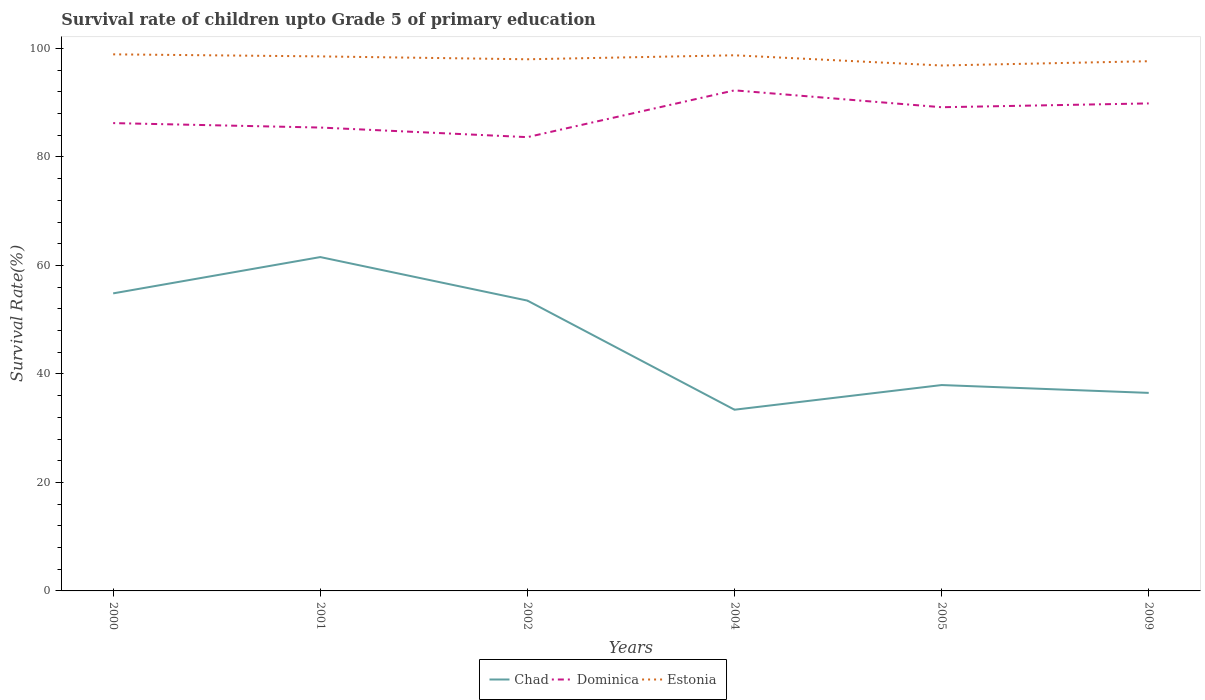Does the line corresponding to Dominica intersect with the line corresponding to Estonia?
Give a very brief answer. No. Across all years, what is the maximum survival rate of children in Estonia?
Provide a succinct answer. 96.86. In which year was the survival rate of children in Chad maximum?
Keep it short and to the point. 2004. What is the total survival rate of children in Chad in the graph?
Provide a succinct answer. -6.69. What is the difference between the highest and the second highest survival rate of children in Dominica?
Your answer should be compact. 8.63. Is the survival rate of children in Estonia strictly greater than the survival rate of children in Dominica over the years?
Provide a succinct answer. No. Are the values on the major ticks of Y-axis written in scientific E-notation?
Ensure brevity in your answer.  No. How many legend labels are there?
Give a very brief answer. 3. What is the title of the graph?
Ensure brevity in your answer.  Survival rate of children upto Grade 5 of primary education. What is the label or title of the X-axis?
Your answer should be compact. Years. What is the label or title of the Y-axis?
Ensure brevity in your answer.  Survival Rate(%). What is the Survival Rate(%) in Chad in 2000?
Your response must be concise. 54.85. What is the Survival Rate(%) of Dominica in 2000?
Provide a short and direct response. 86.24. What is the Survival Rate(%) of Estonia in 2000?
Offer a very short reply. 98.91. What is the Survival Rate(%) in Chad in 2001?
Your answer should be very brief. 61.54. What is the Survival Rate(%) of Dominica in 2001?
Your answer should be very brief. 85.42. What is the Survival Rate(%) in Estonia in 2001?
Your answer should be compact. 98.54. What is the Survival Rate(%) in Chad in 2002?
Your answer should be compact. 53.52. What is the Survival Rate(%) in Dominica in 2002?
Give a very brief answer. 83.65. What is the Survival Rate(%) of Estonia in 2002?
Your answer should be compact. 98.01. What is the Survival Rate(%) in Chad in 2004?
Provide a short and direct response. 33.41. What is the Survival Rate(%) of Dominica in 2004?
Ensure brevity in your answer.  92.28. What is the Survival Rate(%) of Estonia in 2004?
Offer a very short reply. 98.74. What is the Survival Rate(%) of Chad in 2005?
Your response must be concise. 37.95. What is the Survival Rate(%) of Dominica in 2005?
Your response must be concise. 89.17. What is the Survival Rate(%) of Estonia in 2005?
Your response must be concise. 96.86. What is the Survival Rate(%) of Chad in 2009?
Your response must be concise. 36.51. What is the Survival Rate(%) in Dominica in 2009?
Provide a succinct answer. 89.87. What is the Survival Rate(%) in Estonia in 2009?
Provide a succinct answer. 97.65. Across all years, what is the maximum Survival Rate(%) of Chad?
Ensure brevity in your answer.  61.54. Across all years, what is the maximum Survival Rate(%) in Dominica?
Keep it short and to the point. 92.28. Across all years, what is the maximum Survival Rate(%) in Estonia?
Make the answer very short. 98.91. Across all years, what is the minimum Survival Rate(%) of Chad?
Give a very brief answer. 33.41. Across all years, what is the minimum Survival Rate(%) of Dominica?
Your response must be concise. 83.65. Across all years, what is the minimum Survival Rate(%) of Estonia?
Make the answer very short. 96.86. What is the total Survival Rate(%) in Chad in the graph?
Provide a short and direct response. 277.78. What is the total Survival Rate(%) of Dominica in the graph?
Your response must be concise. 526.62. What is the total Survival Rate(%) of Estonia in the graph?
Provide a succinct answer. 588.7. What is the difference between the Survival Rate(%) in Chad in 2000 and that in 2001?
Make the answer very short. -6.69. What is the difference between the Survival Rate(%) in Dominica in 2000 and that in 2001?
Make the answer very short. 0.82. What is the difference between the Survival Rate(%) of Estonia in 2000 and that in 2001?
Give a very brief answer. 0.38. What is the difference between the Survival Rate(%) in Chad in 2000 and that in 2002?
Offer a terse response. 1.33. What is the difference between the Survival Rate(%) in Dominica in 2000 and that in 2002?
Make the answer very short. 2.59. What is the difference between the Survival Rate(%) of Estonia in 2000 and that in 2002?
Keep it short and to the point. 0.91. What is the difference between the Survival Rate(%) of Chad in 2000 and that in 2004?
Keep it short and to the point. 21.44. What is the difference between the Survival Rate(%) in Dominica in 2000 and that in 2004?
Provide a short and direct response. -6.04. What is the difference between the Survival Rate(%) in Estonia in 2000 and that in 2004?
Offer a very short reply. 0.17. What is the difference between the Survival Rate(%) in Chad in 2000 and that in 2005?
Ensure brevity in your answer.  16.9. What is the difference between the Survival Rate(%) in Dominica in 2000 and that in 2005?
Keep it short and to the point. -2.93. What is the difference between the Survival Rate(%) of Estonia in 2000 and that in 2005?
Provide a short and direct response. 2.06. What is the difference between the Survival Rate(%) of Chad in 2000 and that in 2009?
Your response must be concise. 18.34. What is the difference between the Survival Rate(%) of Dominica in 2000 and that in 2009?
Ensure brevity in your answer.  -3.63. What is the difference between the Survival Rate(%) in Estonia in 2000 and that in 2009?
Offer a terse response. 1.27. What is the difference between the Survival Rate(%) in Chad in 2001 and that in 2002?
Your answer should be compact. 8.02. What is the difference between the Survival Rate(%) of Dominica in 2001 and that in 2002?
Your answer should be compact. 1.77. What is the difference between the Survival Rate(%) in Estonia in 2001 and that in 2002?
Your answer should be very brief. 0.53. What is the difference between the Survival Rate(%) in Chad in 2001 and that in 2004?
Provide a short and direct response. 28.14. What is the difference between the Survival Rate(%) in Dominica in 2001 and that in 2004?
Provide a succinct answer. -6.86. What is the difference between the Survival Rate(%) in Estonia in 2001 and that in 2004?
Provide a short and direct response. -0.2. What is the difference between the Survival Rate(%) of Chad in 2001 and that in 2005?
Ensure brevity in your answer.  23.59. What is the difference between the Survival Rate(%) of Dominica in 2001 and that in 2005?
Offer a terse response. -3.75. What is the difference between the Survival Rate(%) of Estonia in 2001 and that in 2005?
Offer a very short reply. 1.68. What is the difference between the Survival Rate(%) in Chad in 2001 and that in 2009?
Your response must be concise. 25.04. What is the difference between the Survival Rate(%) of Dominica in 2001 and that in 2009?
Keep it short and to the point. -4.45. What is the difference between the Survival Rate(%) in Estonia in 2001 and that in 2009?
Your answer should be very brief. 0.89. What is the difference between the Survival Rate(%) in Chad in 2002 and that in 2004?
Make the answer very short. 20.12. What is the difference between the Survival Rate(%) of Dominica in 2002 and that in 2004?
Your answer should be compact. -8.63. What is the difference between the Survival Rate(%) of Estonia in 2002 and that in 2004?
Give a very brief answer. -0.73. What is the difference between the Survival Rate(%) of Chad in 2002 and that in 2005?
Provide a succinct answer. 15.57. What is the difference between the Survival Rate(%) in Dominica in 2002 and that in 2005?
Your response must be concise. -5.51. What is the difference between the Survival Rate(%) in Estonia in 2002 and that in 2005?
Provide a short and direct response. 1.15. What is the difference between the Survival Rate(%) in Chad in 2002 and that in 2009?
Provide a succinct answer. 17.01. What is the difference between the Survival Rate(%) in Dominica in 2002 and that in 2009?
Provide a short and direct response. -6.22. What is the difference between the Survival Rate(%) of Estonia in 2002 and that in 2009?
Your response must be concise. 0.36. What is the difference between the Survival Rate(%) in Chad in 2004 and that in 2005?
Offer a terse response. -4.54. What is the difference between the Survival Rate(%) of Dominica in 2004 and that in 2005?
Your response must be concise. 3.11. What is the difference between the Survival Rate(%) of Estonia in 2004 and that in 2005?
Your answer should be compact. 1.88. What is the difference between the Survival Rate(%) in Chad in 2004 and that in 2009?
Your answer should be very brief. -3.1. What is the difference between the Survival Rate(%) of Dominica in 2004 and that in 2009?
Your answer should be very brief. 2.41. What is the difference between the Survival Rate(%) of Estonia in 2004 and that in 2009?
Provide a short and direct response. 1.09. What is the difference between the Survival Rate(%) of Chad in 2005 and that in 2009?
Make the answer very short. 1.44. What is the difference between the Survival Rate(%) in Dominica in 2005 and that in 2009?
Keep it short and to the point. -0.7. What is the difference between the Survival Rate(%) of Estonia in 2005 and that in 2009?
Give a very brief answer. -0.79. What is the difference between the Survival Rate(%) in Chad in 2000 and the Survival Rate(%) in Dominica in 2001?
Give a very brief answer. -30.57. What is the difference between the Survival Rate(%) of Chad in 2000 and the Survival Rate(%) of Estonia in 2001?
Your answer should be compact. -43.69. What is the difference between the Survival Rate(%) in Dominica in 2000 and the Survival Rate(%) in Estonia in 2001?
Your answer should be compact. -12.3. What is the difference between the Survival Rate(%) of Chad in 2000 and the Survival Rate(%) of Dominica in 2002?
Provide a short and direct response. -28.8. What is the difference between the Survival Rate(%) of Chad in 2000 and the Survival Rate(%) of Estonia in 2002?
Keep it short and to the point. -43.15. What is the difference between the Survival Rate(%) of Dominica in 2000 and the Survival Rate(%) of Estonia in 2002?
Make the answer very short. -11.77. What is the difference between the Survival Rate(%) of Chad in 2000 and the Survival Rate(%) of Dominica in 2004?
Offer a very short reply. -37.43. What is the difference between the Survival Rate(%) of Chad in 2000 and the Survival Rate(%) of Estonia in 2004?
Your answer should be compact. -43.89. What is the difference between the Survival Rate(%) of Dominica in 2000 and the Survival Rate(%) of Estonia in 2004?
Provide a short and direct response. -12.5. What is the difference between the Survival Rate(%) of Chad in 2000 and the Survival Rate(%) of Dominica in 2005?
Provide a succinct answer. -34.31. What is the difference between the Survival Rate(%) in Chad in 2000 and the Survival Rate(%) in Estonia in 2005?
Provide a short and direct response. -42.01. What is the difference between the Survival Rate(%) of Dominica in 2000 and the Survival Rate(%) of Estonia in 2005?
Make the answer very short. -10.62. What is the difference between the Survival Rate(%) in Chad in 2000 and the Survival Rate(%) in Dominica in 2009?
Your answer should be very brief. -35.02. What is the difference between the Survival Rate(%) of Chad in 2000 and the Survival Rate(%) of Estonia in 2009?
Your answer should be compact. -42.8. What is the difference between the Survival Rate(%) in Dominica in 2000 and the Survival Rate(%) in Estonia in 2009?
Ensure brevity in your answer.  -11.41. What is the difference between the Survival Rate(%) of Chad in 2001 and the Survival Rate(%) of Dominica in 2002?
Offer a very short reply. -22.11. What is the difference between the Survival Rate(%) of Chad in 2001 and the Survival Rate(%) of Estonia in 2002?
Make the answer very short. -36.46. What is the difference between the Survival Rate(%) in Dominica in 2001 and the Survival Rate(%) in Estonia in 2002?
Your response must be concise. -12.59. What is the difference between the Survival Rate(%) in Chad in 2001 and the Survival Rate(%) in Dominica in 2004?
Offer a terse response. -30.73. What is the difference between the Survival Rate(%) in Chad in 2001 and the Survival Rate(%) in Estonia in 2004?
Keep it short and to the point. -37.2. What is the difference between the Survival Rate(%) of Dominica in 2001 and the Survival Rate(%) of Estonia in 2004?
Keep it short and to the point. -13.32. What is the difference between the Survival Rate(%) in Chad in 2001 and the Survival Rate(%) in Dominica in 2005?
Provide a succinct answer. -27.62. What is the difference between the Survival Rate(%) of Chad in 2001 and the Survival Rate(%) of Estonia in 2005?
Your answer should be very brief. -35.32. What is the difference between the Survival Rate(%) of Dominica in 2001 and the Survival Rate(%) of Estonia in 2005?
Your answer should be very brief. -11.44. What is the difference between the Survival Rate(%) in Chad in 2001 and the Survival Rate(%) in Dominica in 2009?
Keep it short and to the point. -28.33. What is the difference between the Survival Rate(%) in Chad in 2001 and the Survival Rate(%) in Estonia in 2009?
Your answer should be compact. -36.1. What is the difference between the Survival Rate(%) in Dominica in 2001 and the Survival Rate(%) in Estonia in 2009?
Your response must be concise. -12.23. What is the difference between the Survival Rate(%) of Chad in 2002 and the Survival Rate(%) of Dominica in 2004?
Keep it short and to the point. -38.76. What is the difference between the Survival Rate(%) in Chad in 2002 and the Survival Rate(%) in Estonia in 2004?
Ensure brevity in your answer.  -45.22. What is the difference between the Survival Rate(%) of Dominica in 2002 and the Survival Rate(%) of Estonia in 2004?
Make the answer very short. -15.09. What is the difference between the Survival Rate(%) in Chad in 2002 and the Survival Rate(%) in Dominica in 2005?
Offer a very short reply. -35.64. What is the difference between the Survival Rate(%) in Chad in 2002 and the Survival Rate(%) in Estonia in 2005?
Ensure brevity in your answer.  -43.34. What is the difference between the Survival Rate(%) in Dominica in 2002 and the Survival Rate(%) in Estonia in 2005?
Give a very brief answer. -13.21. What is the difference between the Survival Rate(%) of Chad in 2002 and the Survival Rate(%) of Dominica in 2009?
Your answer should be very brief. -36.35. What is the difference between the Survival Rate(%) in Chad in 2002 and the Survival Rate(%) in Estonia in 2009?
Offer a terse response. -44.13. What is the difference between the Survival Rate(%) of Dominica in 2002 and the Survival Rate(%) of Estonia in 2009?
Keep it short and to the point. -14. What is the difference between the Survival Rate(%) in Chad in 2004 and the Survival Rate(%) in Dominica in 2005?
Make the answer very short. -55.76. What is the difference between the Survival Rate(%) of Chad in 2004 and the Survival Rate(%) of Estonia in 2005?
Ensure brevity in your answer.  -63.45. What is the difference between the Survival Rate(%) in Dominica in 2004 and the Survival Rate(%) in Estonia in 2005?
Your answer should be very brief. -4.58. What is the difference between the Survival Rate(%) in Chad in 2004 and the Survival Rate(%) in Dominica in 2009?
Give a very brief answer. -56.46. What is the difference between the Survival Rate(%) in Chad in 2004 and the Survival Rate(%) in Estonia in 2009?
Provide a succinct answer. -64.24. What is the difference between the Survival Rate(%) in Dominica in 2004 and the Survival Rate(%) in Estonia in 2009?
Your response must be concise. -5.37. What is the difference between the Survival Rate(%) of Chad in 2005 and the Survival Rate(%) of Dominica in 2009?
Offer a terse response. -51.92. What is the difference between the Survival Rate(%) in Chad in 2005 and the Survival Rate(%) in Estonia in 2009?
Your answer should be very brief. -59.7. What is the difference between the Survival Rate(%) in Dominica in 2005 and the Survival Rate(%) in Estonia in 2009?
Keep it short and to the point. -8.48. What is the average Survival Rate(%) in Chad per year?
Your response must be concise. 46.3. What is the average Survival Rate(%) of Dominica per year?
Your answer should be very brief. 87.77. What is the average Survival Rate(%) in Estonia per year?
Ensure brevity in your answer.  98.12. In the year 2000, what is the difference between the Survival Rate(%) in Chad and Survival Rate(%) in Dominica?
Provide a short and direct response. -31.39. In the year 2000, what is the difference between the Survival Rate(%) in Chad and Survival Rate(%) in Estonia?
Your answer should be very brief. -44.06. In the year 2000, what is the difference between the Survival Rate(%) of Dominica and Survival Rate(%) of Estonia?
Your answer should be very brief. -12.67. In the year 2001, what is the difference between the Survival Rate(%) in Chad and Survival Rate(%) in Dominica?
Ensure brevity in your answer.  -23.88. In the year 2001, what is the difference between the Survival Rate(%) in Chad and Survival Rate(%) in Estonia?
Ensure brevity in your answer.  -36.99. In the year 2001, what is the difference between the Survival Rate(%) in Dominica and Survival Rate(%) in Estonia?
Keep it short and to the point. -13.12. In the year 2002, what is the difference between the Survival Rate(%) of Chad and Survival Rate(%) of Dominica?
Keep it short and to the point. -30.13. In the year 2002, what is the difference between the Survival Rate(%) in Chad and Survival Rate(%) in Estonia?
Give a very brief answer. -44.48. In the year 2002, what is the difference between the Survival Rate(%) of Dominica and Survival Rate(%) of Estonia?
Your answer should be very brief. -14.35. In the year 2004, what is the difference between the Survival Rate(%) of Chad and Survival Rate(%) of Dominica?
Your response must be concise. -58.87. In the year 2004, what is the difference between the Survival Rate(%) in Chad and Survival Rate(%) in Estonia?
Offer a terse response. -65.33. In the year 2004, what is the difference between the Survival Rate(%) in Dominica and Survival Rate(%) in Estonia?
Your answer should be compact. -6.46. In the year 2005, what is the difference between the Survival Rate(%) of Chad and Survival Rate(%) of Dominica?
Make the answer very short. -51.22. In the year 2005, what is the difference between the Survival Rate(%) in Chad and Survival Rate(%) in Estonia?
Your response must be concise. -58.91. In the year 2005, what is the difference between the Survival Rate(%) in Dominica and Survival Rate(%) in Estonia?
Ensure brevity in your answer.  -7.69. In the year 2009, what is the difference between the Survival Rate(%) in Chad and Survival Rate(%) in Dominica?
Offer a terse response. -53.36. In the year 2009, what is the difference between the Survival Rate(%) of Chad and Survival Rate(%) of Estonia?
Make the answer very short. -61.14. In the year 2009, what is the difference between the Survival Rate(%) in Dominica and Survival Rate(%) in Estonia?
Your answer should be very brief. -7.78. What is the ratio of the Survival Rate(%) in Chad in 2000 to that in 2001?
Ensure brevity in your answer.  0.89. What is the ratio of the Survival Rate(%) in Dominica in 2000 to that in 2001?
Your answer should be compact. 1.01. What is the ratio of the Survival Rate(%) of Estonia in 2000 to that in 2001?
Your answer should be very brief. 1. What is the ratio of the Survival Rate(%) in Chad in 2000 to that in 2002?
Give a very brief answer. 1.02. What is the ratio of the Survival Rate(%) in Dominica in 2000 to that in 2002?
Ensure brevity in your answer.  1.03. What is the ratio of the Survival Rate(%) in Estonia in 2000 to that in 2002?
Provide a succinct answer. 1.01. What is the ratio of the Survival Rate(%) of Chad in 2000 to that in 2004?
Keep it short and to the point. 1.64. What is the ratio of the Survival Rate(%) in Dominica in 2000 to that in 2004?
Your response must be concise. 0.93. What is the ratio of the Survival Rate(%) of Estonia in 2000 to that in 2004?
Provide a succinct answer. 1. What is the ratio of the Survival Rate(%) in Chad in 2000 to that in 2005?
Provide a short and direct response. 1.45. What is the ratio of the Survival Rate(%) of Dominica in 2000 to that in 2005?
Your answer should be compact. 0.97. What is the ratio of the Survival Rate(%) in Estonia in 2000 to that in 2005?
Offer a terse response. 1.02. What is the ratio of the Survival Rate(%) of Chad in 2000 to that in 2009?
Your answer should be very brief. 1.5. What is the ratio of the Survival Rate(%) of Dominica in 2000 to that in 2009?
Your answer should be very brief. 0.96. What is the ratio of the Survival Rate(%) of Estonia in 2000 to that in 2009?
Provide a succinct answer. 1.01. What is the ratio of the Survival Rate(%) in Chad in 2001 to that in 2002?
Provide a succinct answer. 1.15. What is the ratio of the Survival Rate(%) of Dominica in 2001 to that in 2002?
Offer a terse response. 1.02. What is the ratio of the Survival Rate(%) in Estonia in 2001 to that in 2002?
Make the answer very short. 1.01. What is the ratio of the Survival Rate(%) of Chad in 2001 to that in 2004?
Offer a terse response. 1.84. What is the ratio of the Survival Rate(%) in Dominica in 2001 to that in 2004?
Offer a very short reply. 0.93. What is the ratio of the Survival Rate(%) of Chad in 2001 to that in 2005?
Your answer should be very brief. 1.62. What is the ratio of the Survival Rate(%) of Dominica in 2001 to that in 2005?
Offer a very short reply. 0.96. What is the ratio of the Survival Rate(%) in Estonia in 2001 to that in 2005?
Your response must be concise. 1.02. What is the ratio of the Survival Rate(%) in Chad in 2001 to that in 2009?
Offer a very short reply. 1.69. What is the ratio of the Survival Rate(%) of Dominica in 2001 to that in 2009?
Your answer should be compact. 0.95. What is the ratio of the Survival Rate(%) in Estonia in 2001 to that in 2009?
Make the answer very short. 1.01. What is the ratio of the Survival Rate(%) of Chad in 2002 to that in 2004?
Your answer should be very brief. 1.6. What is the ratio of the Survival Rate(%) of Dominica in 2002 to that in 2004?
Your response must be concise. 0.91. What is the ratio of the Survival Rate(%) of Estonia in 2002 to that in 2004?
Your answer should be compact. 0.99. What is the ratio of the Survival Rate(%) of Chad in 2002 to that in 2005?
Provide a succinct answer. 1.41. What is the ratio of the Survival Rate(%) of Dominica in 2002 to that in 2005?
Offer a very short reply. 0.94. What is the ratio of the Survival Rate(%) of Estonia in 2002 to that in 2005?
Provide a short and direct response. 1.01. What is the ratio of the Survival Rate(%) of Chad in 2002 to that in 2009?
Make the answer very short. 1.47. What is the ratio of the Survival Rate(%) of Dominica in 2002 to that in 2009?
Your answer should be very brief. 0.93. What is the ratio of the Survival Rate(%) in Estonia in 2002 to that in 2009?
Your response must be concise. 1. What is the ratio of the Survival Rate(%) of Chad in 2004 to that in 2005?
Keep it short and to the point. 0.88. What is the ratio of the Survival Rate(%) of Dominica in 2004 to that in 2005?
Make the answer very short. 1.03. What is the ratio of the Survival Rate(%) in Estonia in 2004 to that in 2005?
Give a very brief answer. 1.02. What is the ratio of the Survival Rate(%) in Chad in 2004 to that in 2009?
Provide a succinct answer. 0.92. What is the ratio of the Survival Rate(%) in Dominica in 2004 to that in 2009?
Your answer should be very brief. 1.03. What is the ratio of the Survival Rate(%) of Estonia in 2004 to that in 2009?
Give a very brief answer. 1.01. What is the ratio of the Survival Rate(%) of Chad in 2005 to that in 2009?
Provide a short and direct response. 1.04. What is the ratio of the Survival Rate(%) of Dominica in 2005 to that in 2009?
Your answer should be very brief. 0.99. What is the difference between the highest and the second highest Survival Rate(%) of Chad?
Make the answer very short. 6.69. What is the difference between the highest and the second highest Survival Rate(%) in Dominica?
Provide a succinct answer. 2.41. What is the difference between the highest and the second highest Survival Rate(%) of Estonia?
Offer a very short reply. 0.17. What is the difference between the highest and the lowest Survival Rate(%) in Chad?
Offer a terse response. 28.14. What is the difference between the highest and the lowest Survival Rate(%) in Dominica?
Provide a short and direct response. 8.63. What is the difference between the highest and the lowest Survival Rate(%) of Estonia?
Give a very brief answer. 2.06. 